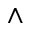<formula> <loc_0><loc_0><loc_500><loc_500>\wedge</formula> 